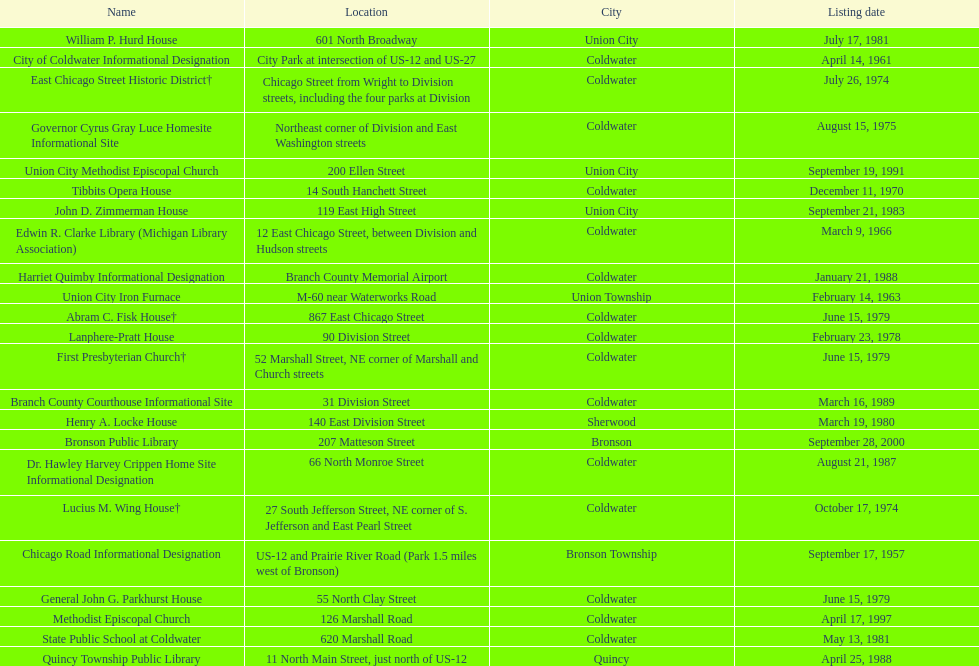Which city has the largest number of historic sites? Coldwater. 